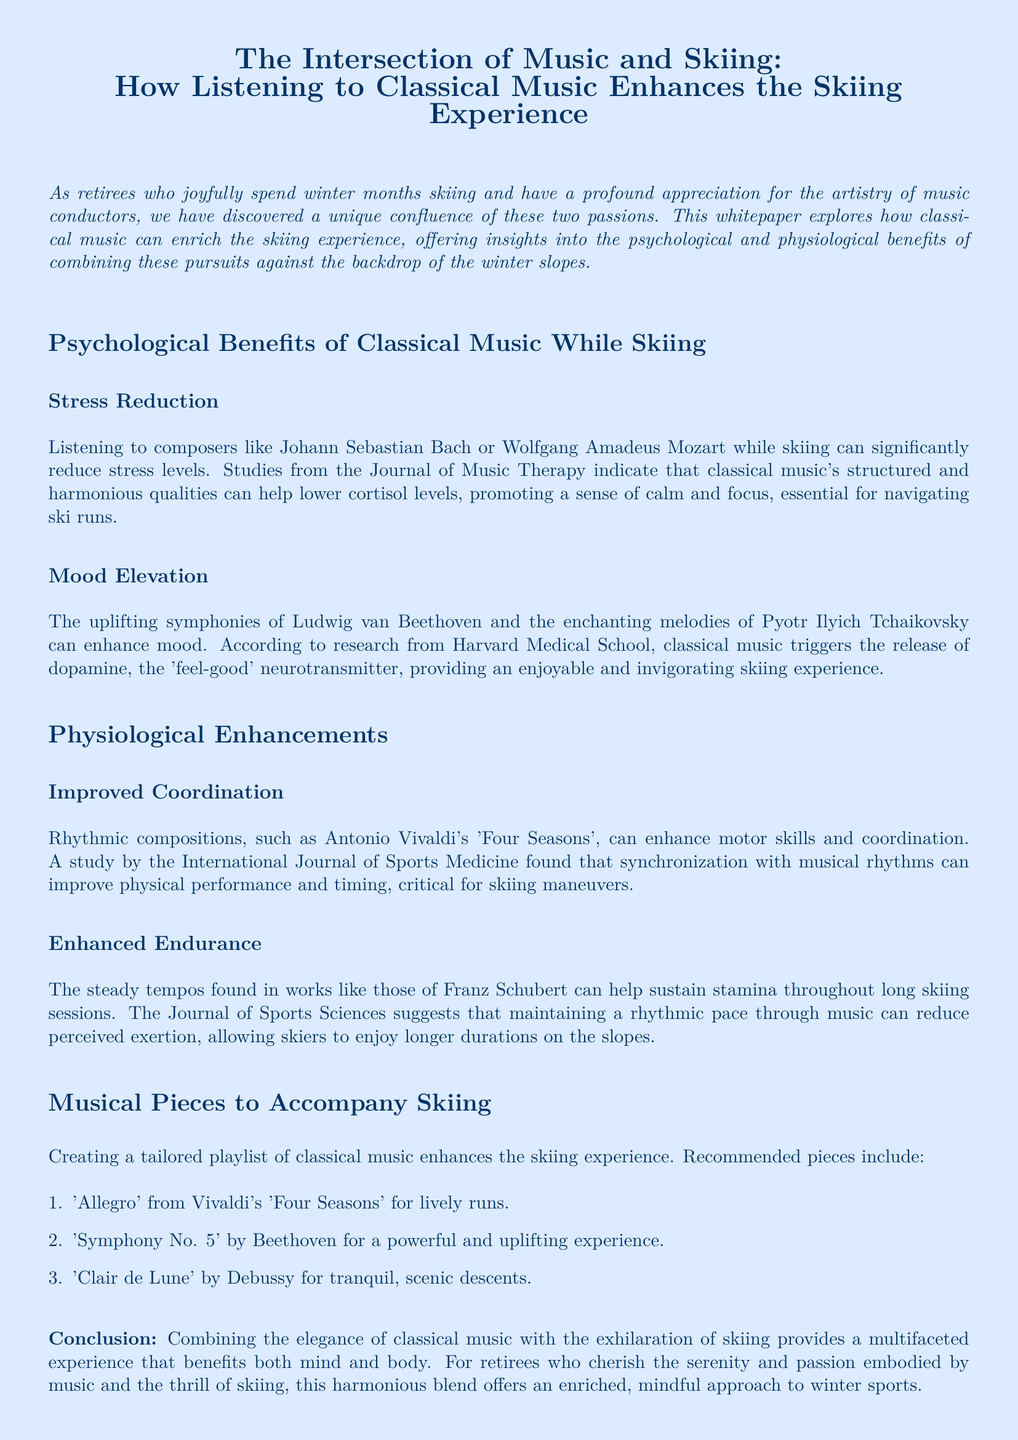What are the psychological benefits of classical music while skiing? The document outlines stress reduction and mood elevation as key psychological benefits of classical music while skiing.
Answer: Stress reduction, mood elevation Which composers are mentioned for stress reduction? Johann Sebastian Bach and Wolfgang Amadeus Mozart are specifically named in relation to stress reduction.
Answer: Johann Sebastian Bach, Wolfgang Amadeus Mozart What piece of music is suggested for lively runs? The whitepaper recommends 'Allegro' from Vivaldi's 'Four Seasons' for lively skiing runs.
Answer: 'Allegro' from Vivaldi's 'Four Seasons' What impact does classical music have on coordination? The document states that rhythmic compositions can enhance motor skills and coordination.
Answer: Enhance motor skills and coordination Which neurotransmitter is released by classical music according to the document? The whitepaper cites dopamine as the 'feel-good' neurotransmitter released by classical music.
Answer: Dopamine How does classical music influence endurance during skiing? According to the document, classical music can help sustain stamina and reduce perceived exertion during skiing.
Answer: Sustain stamina, reduce perceived exertion What is the primary focus of this whitepaper? The main aim of the whitepaper is to explore the intersection of classical music and skiing to enhance the skiing experience.
Answer: Intersection of music and skiing Which journal published a study on stress reduction through music? The Journal of Music Therapy is mentioned for studies related to stress reduction and classical music.
Answer: Journal of Music Therapy 